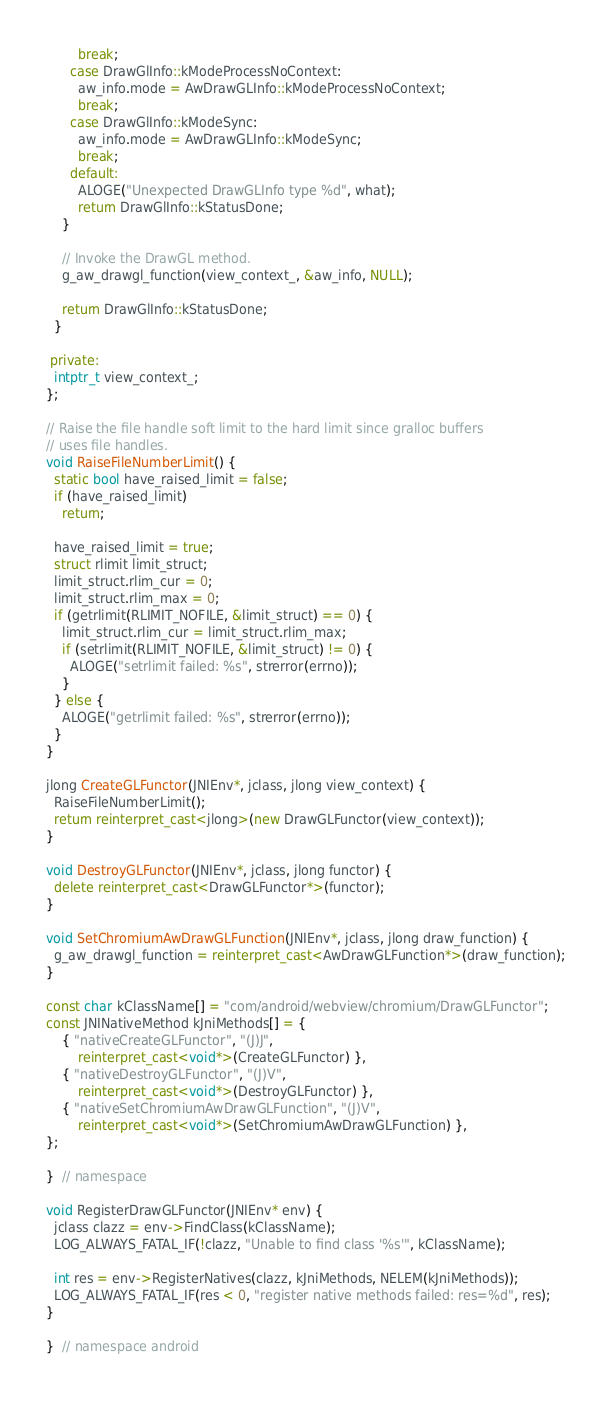Convert code to text. <code><loc_0><loc_0><loc_500><loc_500><_C++_>        break;
      case DrawGlInfo::kModeProcessNoContext:
        aw_info.mode = AwDrawGLInfo::kModeProcessNoContext;
        break;
      case DrawGlInfo::kModeSync:
        aw_info.mode = AwDrawGLInfo::kModeSync;
        break;
      default:
        ALOGE("Unexpected DrawGLInfo type %d", what);
        return DrawGlInfo::kStatusDone;
    }

    // Invoke the DrawGL method.
    g_aw_drawgl_function(view_context_, &aw_info, NULL);

    return DrawGlInfo::kStatusDone;
  }

 private:
  intptr_t view_context_;
};

// Raise the file handle soft limit to the hard limit since gralloc buffers
// uses file handles.
void RaiseFileNumberLimit() {
  static bool have_raised_limit = false;
  if (have_raised_limit)
    return;

  have_raised_limit = true;
  struct rlimit limit_struct;
  limit_struct.rlim_cur = 0;
  limit_struct.rlim_max = 0;
  if (getrlimit(RLIMIT_NOFILE, &limit_struct) == 0) {
    limit_struct.rlim_cur = limit_struct.rlim_max;
    if (setrlimit(RLIMIT_NOFILE, &limit_struct) != 0) {
      ALOGE("setrlimit failed: %s", strerror(errno));
    }
  } else {
    ALOGE("getrlimit failed: %s", strerror(errno));
  }
}

jlong CreateGLFunctor(JNIEnv*, jclass, jlong view_context) {
  RaiseFileNumberLimit();
  return reinterpret_cast<jlong>(new DrawGLFunctor(view_context));
}

void DestroyGLFunctor(JNIEnv*, jclass, jlong functor) {
  delete reinterpret_cast<DrawGLFunctor*>(functor);
}

void SetChromiumAwDrawGLFunction(JNIEnv*, jclass, jlong draw_function) {
  g_aw_drawgl_function = reinterpret_cast<AwDrawGLFunction*>(draw_function);
}

const char kClassName[] = "com/android/webview/chromium/DrawGLFunctor";
const JNINativeMethod kJniMethods[] = {
    { "nativeCreateGLFunctor", "(J)J",
        reinterpret_cast<void*>(CreateGLFunctor) },
    { "nativeDestroyGLFunctor", "(J)V",
        reinterpret_cast<void*>(DestroyGLFunctor) },
    { "nativeSetChromiumAwDrawGLFunction", "(J)V",
        reinterpret_cast<void*>(SetChromiumAwDrawGLFunction) },
};

}  // namespace

void RegisterDrawGLFunctor(JNIEnv* env) {
  jclass clazz = env->FindClass(kClassName);
  LOG_ALWAYS_FATAL_IF(!clazz, "Unable to find class '%s'", kClassName);

  int res = env->RegisterNatives(clazz, kJniMethods, NELEM(kJniMethods));
  LOG_ALWAYS_FATAL_IF(res < 0, "register native methods failed: res=%d", res);
}

}  // namespace android
</code> 